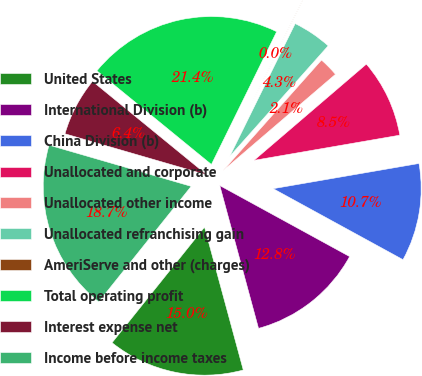<chart> <loc_0><loc_0><loc_500><loc_500><pie_chart><fcel>United States<fcel>International Division (b)<fcel>China Division (b)<fcel>Unallocated and corporate<fcel>Unallocated other income<fcel>Unallocated refranchising gain<fcel>AmeriServe and other (charges)<fcel>Total operating profit<fcel>Interest expense net<fcel>Income before income taxes<nl><fcel>14.96%<fcel>12.82%<fcel>10.69%<fcel>8.55%<fcel>2.15%<fcel>4.29%<fcel>0.02%<fcel>21.36%<fcel>6.42%<fcel>18.75%<nl></chart> 